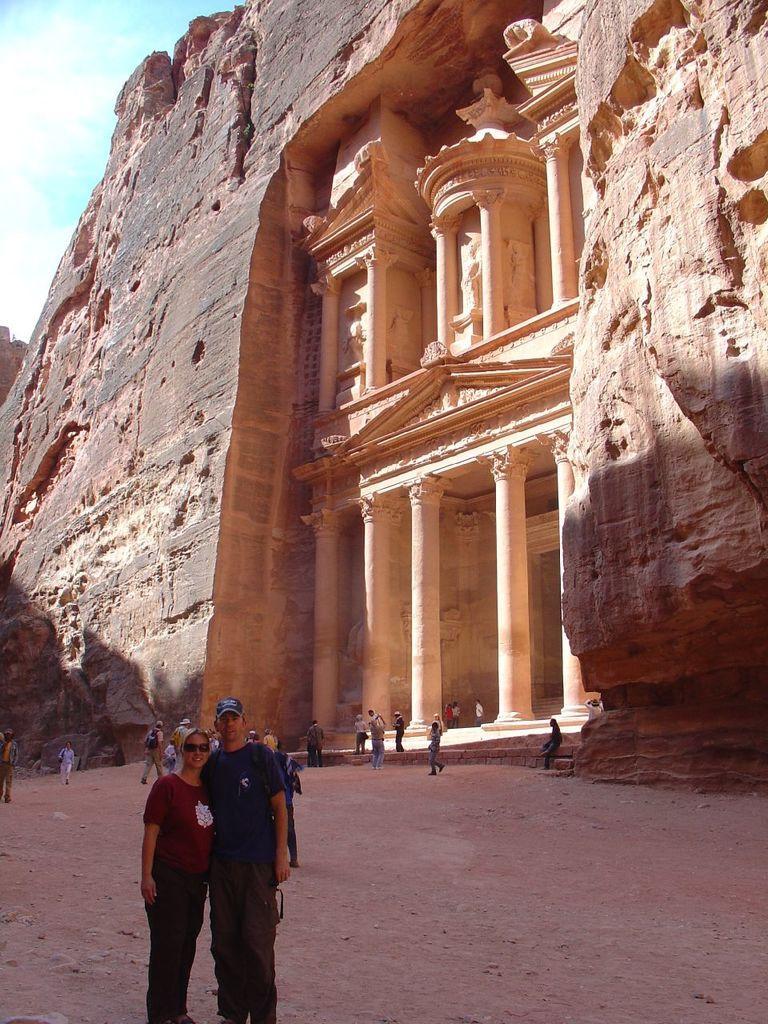Please provide a concise description of this image. In this image there is a monument, there is the sky towards the top of the image, there are persons, there are persons wearing bags, there are pillars, there are sculptors. 